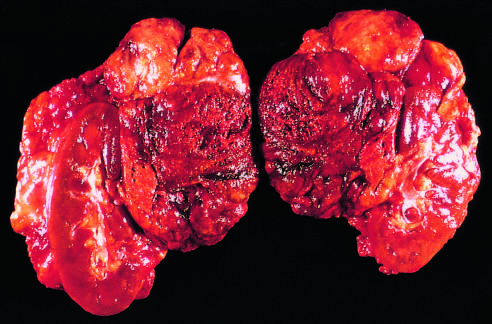s there an extensive mononuclear cell infiltrate in addition to loss of all but a subcapsular rim of cortical cells?
Answer the question using a single word or phrase. Yes 